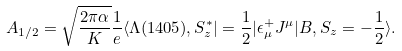<formula> <loc_0><loc_0><loc_500><loc_500>A _ { 1 / 2 } = \sqrt { \frac { 2 \pi \alpha } { K } } \frac { 1 } { e } \langle \Lambda ( 1 4 0 5 ) , S ^ { * } _ { z } | = \frac { 1 } { 2 } | \epsilon ^ { + } _ { \mu } J ^ { \mu } | B , S _ { z } = - \frac { 1 } { 2 } \rangle .</formula> 